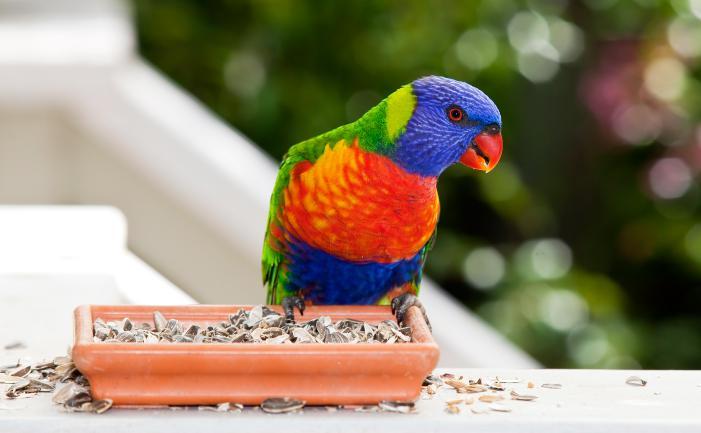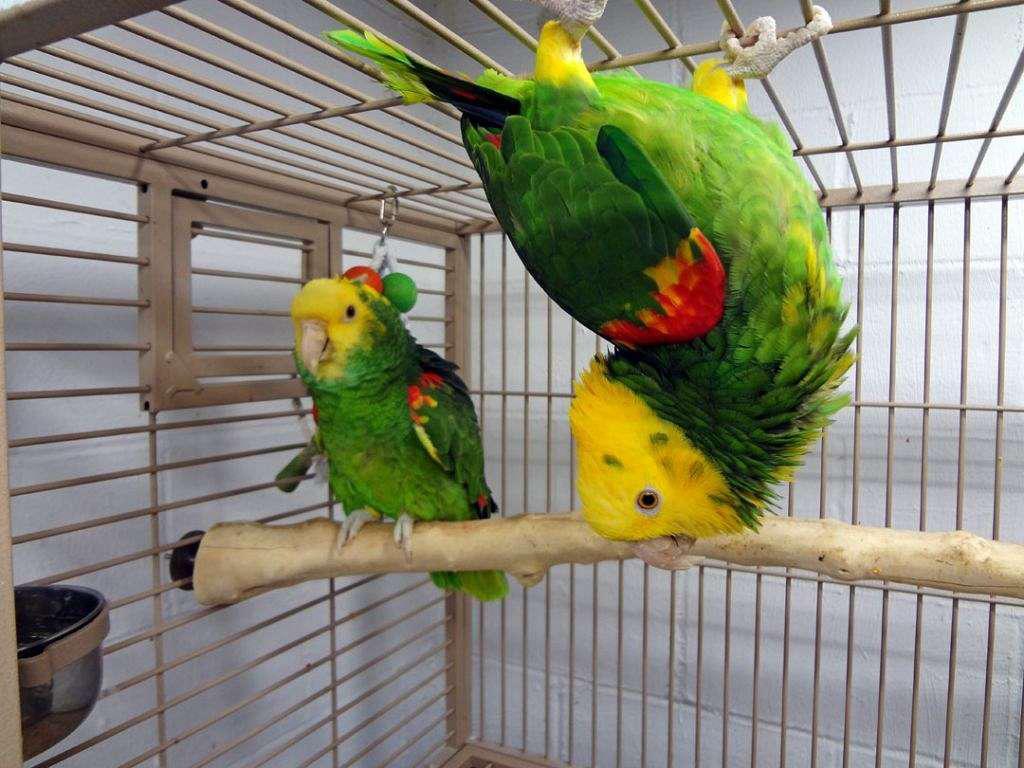The first image is the image on the left, the second image is the image on the right. Considering the images on both sides, is "There is a bird that is hanging with its feet above most of its body." valid? Answer yes or no. Yes. The first image is the image on the left, the second image is the image on the right. For the images displayed, is the sentence "Only one parrot can be seen in each of the images." factually correct? Answer yes or no. No. 